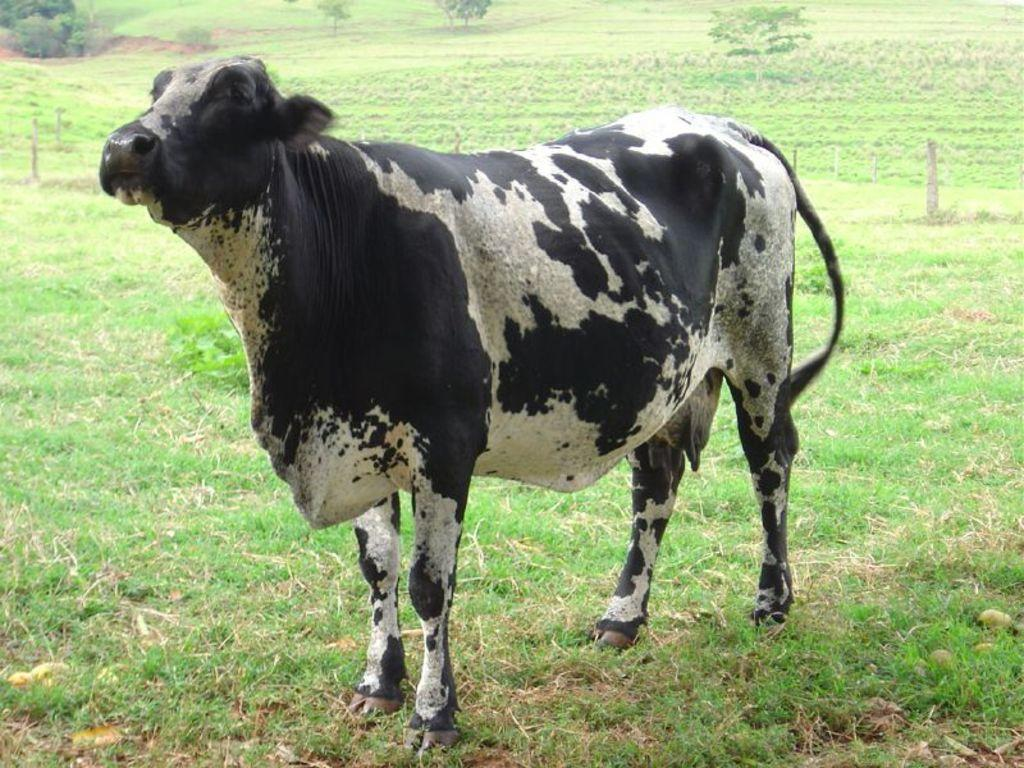What animal is present in the image? There is a cow in the image. What is the cow's position in relation to the ground? The cow is standing on the ground. What type of vegetation covers the ground? The ground is covered with grass. What can be seen in the distance in the image? There are trees visible in the background of the image. What type of plot is the cow teaching in the image? There is no plot or teaching activity present in the image; it features a cow standing on grass with trees in the background. 